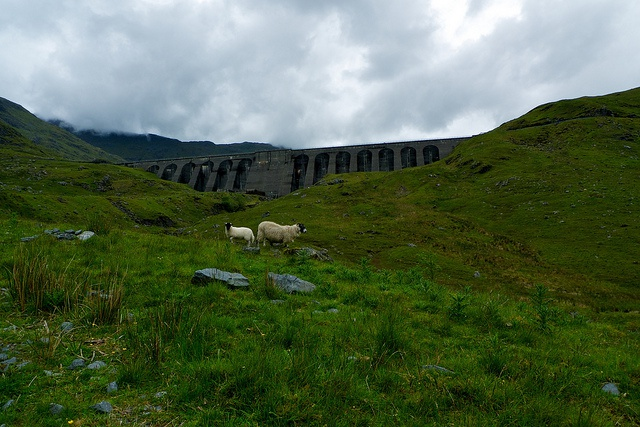Describe the objects in this image and their specific colors. I can see sheep in lightblue, darkgreen, gray, and black tones and sheep in lightblue, black, darkgray, and gray tones in this image. 